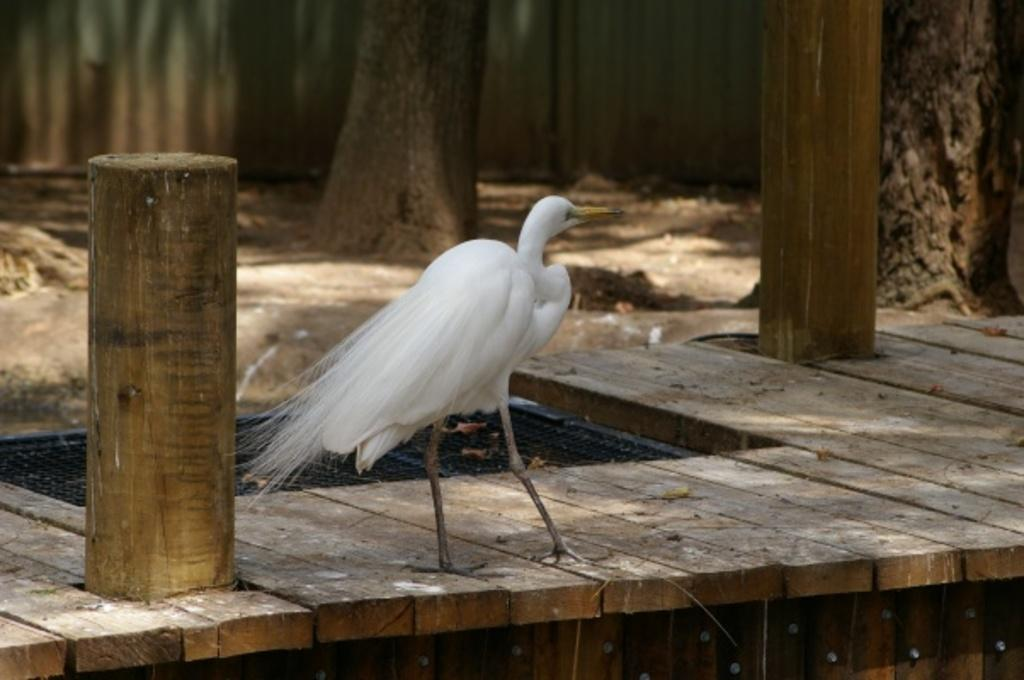What type of animal can be seen in the image? There is a bird in the image. Where is the bird located in the image? The bird is standing on a wooden walk path. What is the main feature in the center of the image? The wooden walk path is in the center of the image. What type of vegetation is visible at the top of the image? There are trees at the top of the image. What brand of toothpaste is the bird using in the image? There is no toothpaste present in the image, and the bird is not using any toothpaste. Can you see a comb in the bird's beak in the image? There is no comb present in the image, and the bird is not holding anything in its beak. 